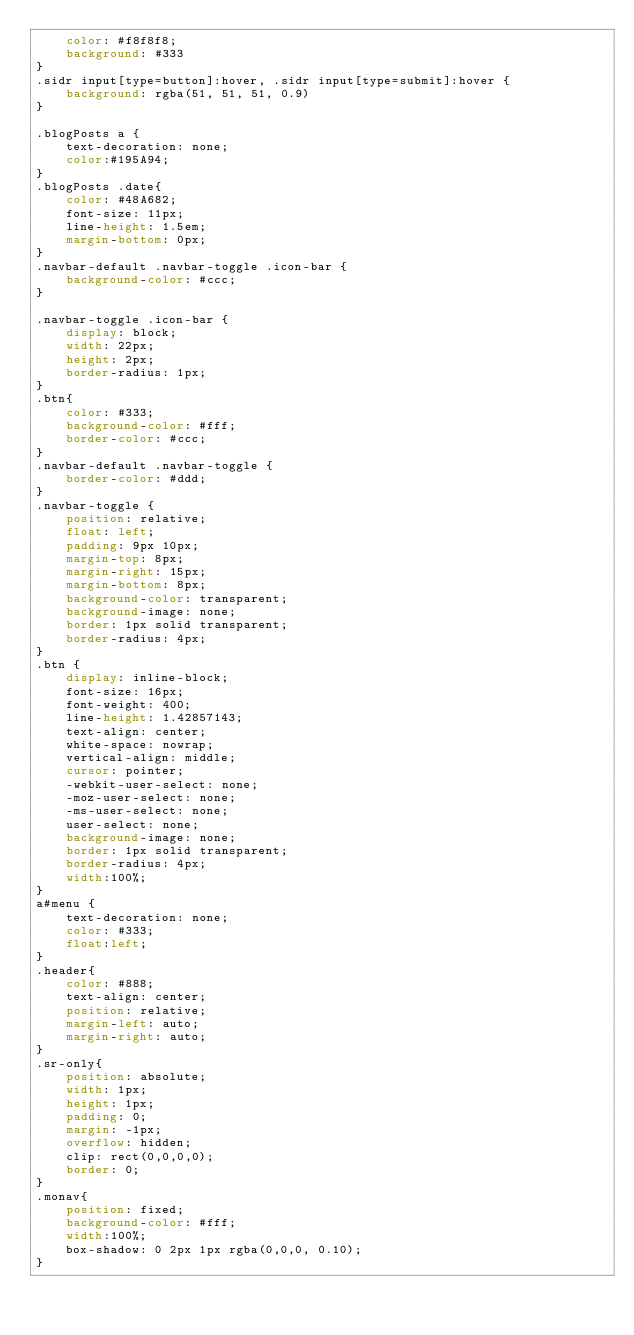Convert code to text. <code><loc_0><loc_0><loc_500><loc_500><_CSS_>    color: #f8f8f8;
    background: #333
}
.sidr input[type=button]:hover, .sidr input[type=submit]:hover {
    background: rgba(51, 51, 51, 0.9)
}

.blogPosts a {
    text-decoration: none;
    color:#195A94;
}
.blogPosts .date{
    color: #48A682;
    font-size: 11px;
    line-height: 1.5em;
    margin-bottom: 0px;
}
.navbar-default .navbar-toggle .icon-bar {
    background-color: #ccc;
}

.navbar-toggle .icon-bar {
    display: block;
    width: 22px;
    height: 2px;
    border-radius: 1px;
}
.btn{
    color: #333;
    background-color: #fff;
    border-color: #ccc;
}
.navbar-default .navbar-toggle {
    border-color: #ddd;
}
.navbar-toggle {
    position: relative;
    float: left;
    padding: 9px 10px;
    margin-top: 8px;
    margin-right: 15px;
    margin-bottom: 8px;
    background-color: transparent;
    background-image: none;
    border: 1px solid transparent;
    border-radius: 4px;
}
.btn {
    display: inline-block;
    font-size: 16px;
    font-weight: 400;
    line-height: 1.42857143;
    text-align: center;
    white-space: nowrap;
    vertical-align: middle;
    cursor: pointer;
    -webkit-user-select: none;
    -moz-user-select: none;
    -ms-user-select: none;
    user-select: none;
    background-image: none;
    border: 1px solid transparent;
    border-radius: 4px;
    width:100%;
}
a#menu {
    text-decoration: none;
    color: #333;
    float:left;
}
.header{
    color: #888;
    text-align: center;
    position: relative;
    margin-left: auto;
    margin-right: auto;
}
.sr-only{
    position: absolute;
    width: 1px;
    height: 1px;
    padding: 0;
    margin: -1px;
    overflow: hidden;
    clip: rect(0,0,0,0);
    border: 0;
}
.monav{
    position: fixed;
    background-color: #fff;
    width:100%;
    box-shadow: 0 2px 1px rgba(0,0,0, 0.10);
}</code> 